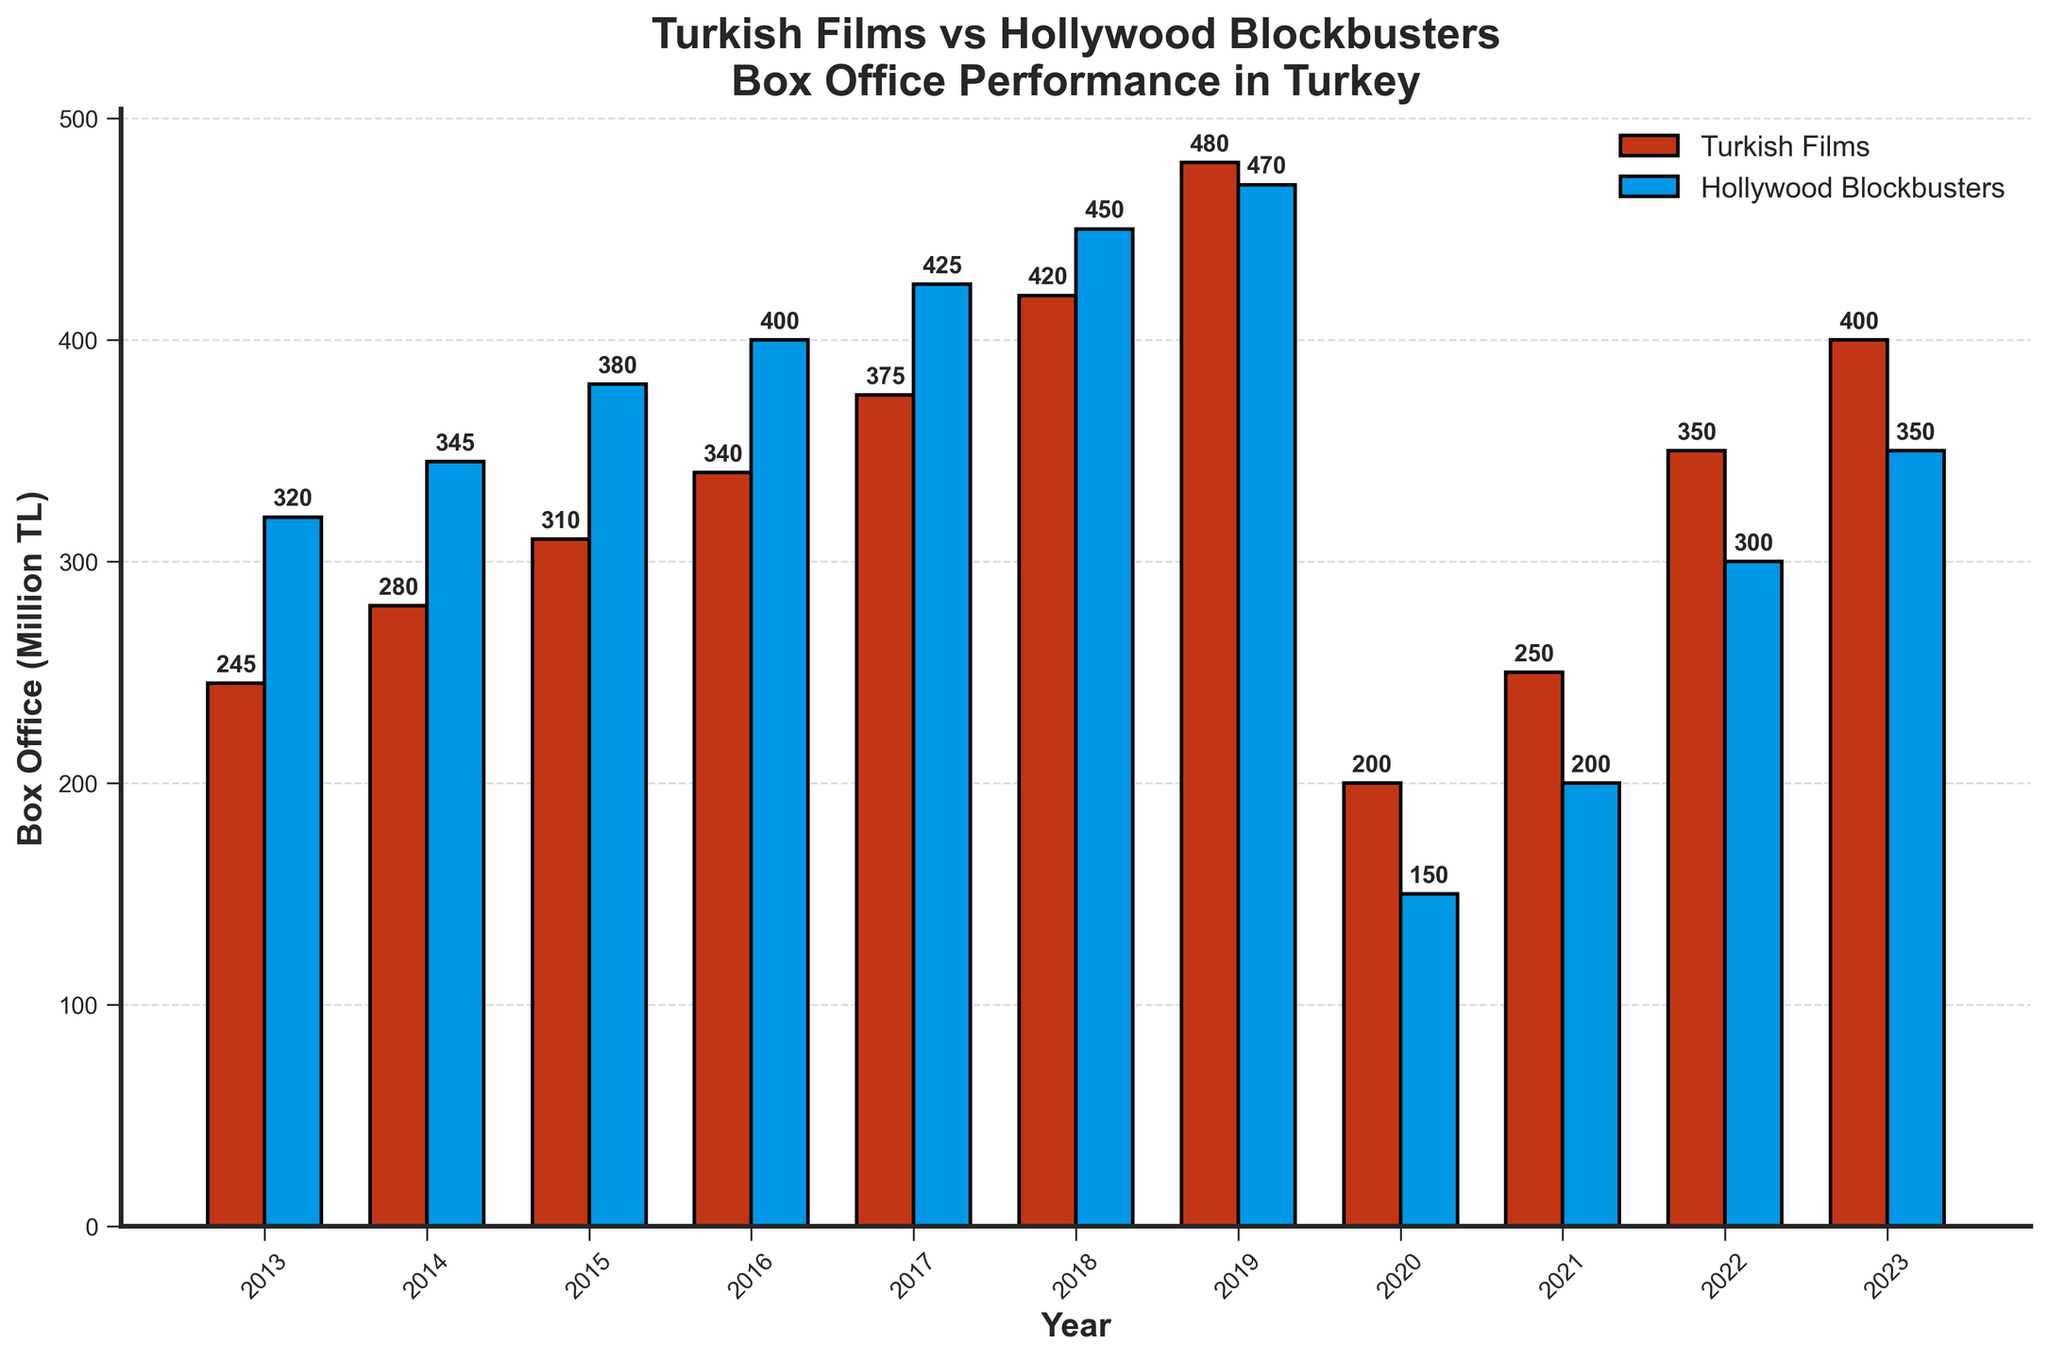What year had the highest box office performance for Turkish Films? Check the highest bar in the Turkish Films (red bars) series. The year associated with this bar is the year with the highest performance.
Answer: 2019 How does the box office revenue for Hollywood Blockbusters in 2020 compare with that in 2013? Locate the blue bars for the years 2020 and 2013. The height of the bar in 2020 (150 million TL) is significantly lower than in 2013 (320 million TL).
Answer: Lower Which year shows the largest difference between the box office revenues of Turkish Films and Hollywood Blockbusters? Calculate the absolute differences for each year and identify the year with the largest value. In 2020, the difference is 50 million TL.
Answer: 2020 What was the revenue for Turkish Films in 2021, and how does it compare to Hollywood Blockbusters that same year? Locate the red and blue bars for 2021. Turkish Films made 250 million TL, while Hollywood Blockbusters made 200 million TL, making Turkish Films higher by 50 million TL.
Answer: 250 million TL; Higher Between which consecutive years did Turkish Films see the greatest increase in box office performance? Observe the red bars and check the year-on-year increase. The largest increase is from 2018 to 2019 (60 million TL).
Answer: 2018 to 2019 In 2023, what is the ratio of Turkish Films' box office revenue to Hollywood Blockbusters' box office revenue? Calculate the ratio: 400 million TL (Turkish Films) to 350 million TL (Hollywood Blockbusters), which is 400/350. Simplify to the nearest whole number.
Answer: 8:7 Which year had the lowest box office revenue for Hollywood Blockbusters and how much was it? Check the blue bars and locate the shortest bar, which corresponds to 2020, with a revenue of 150 million TL.
Answer: 2020; 150 million TL On average, how did the box office performance of Turkish Films compare to Hollywood Blockbusters over the given decade? Sum the revenues for each category over the decade and divide by the number of years (11). Turkish Films have higher average revenue: (3500/11 vs. 3590/11).
Answer: Turkish Films are higher What trend can be observed for Hollywood Blockbusters from 2013 to 2020, and what is the anomaly? Notice the increasing revenue trend until 2019, followed by a significant drop in 2020, likely due to external factors.
Answer: Increasing trend; anomaly in 2020 In which year did both Turkish Films and Hollywood Blockbusters have their closest box office performances, and what were their revenues? Identify the years where red and blue bars are closest in height. In 2020, they are closest: 200 million TL vs. 150 million TL.
Answer: 2020; 200 mln TL (Turkish), 150 mln TL (Hollywood) 